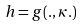Convert formula to latex. <formula><loc_0><loc_0><loc_500><loc_500>h = g ( . , \kappa . )</formula> 